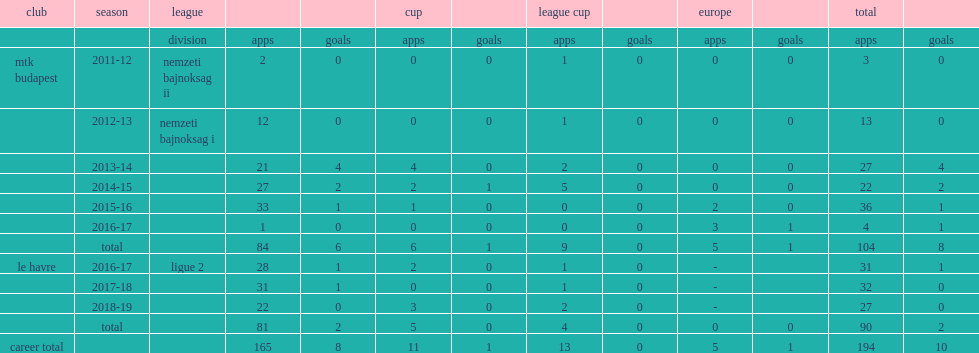Which league did bese play his first match in the 2011-12 season from the mtk budapest? Nemzeti bajnoksag ii. 